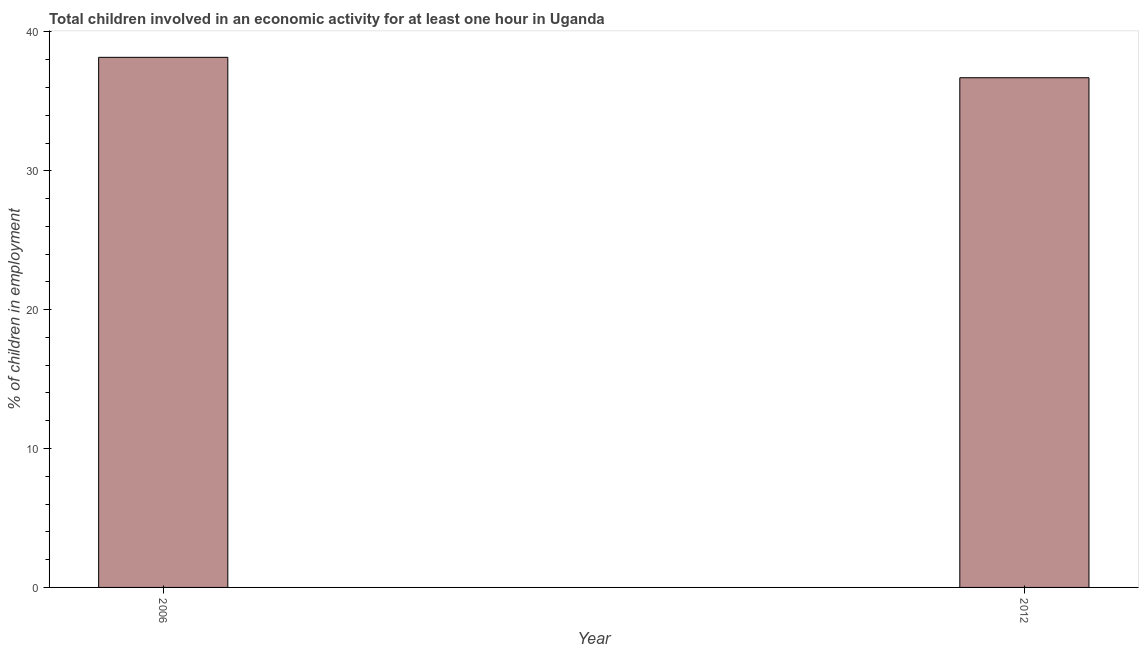Does the graph contain any zero values?
Ensure brevity in your answer.  No. Does the graph contain grids?
Offer a very short reply. No. What is the title of the graph?
Make the answer very short. Total children involved in an economic activity for at least one hour in Uganda. What is the label or title of the Y-axis?
Provide a short and direct response. % of children in employment. What is the percentage of children in employment in 2006?
Offer a terse response. 38.17. Across all years, what is the maximum percentage of children in employment?
Make the answer very short. 38.17. Across all years, what is the minimum percentage of children in employment?
Ensure brevity in your answer.  36.7. What is the sum of the percentage of children in employment?
Provide a succinct answer. 74.87. What is the difference between the percentage of children in employment in 2006 and 2012?
Ensure brevity in your answer.  1.47. What is the average percentage of children in employment per year?
Give a very brief answer. 37.44. What is the median percentage of children in employment?
Provide a succinct answer. 37.44. In how many years, is the percentage of children in employment greater than 38 %?
Offer a terse response. 1. In how many years, is the percentage of children in employment greater than the average percentage of children in employment taken over all years?
Offer a terse response. 1. How many bars are there?
Your answer should be very brief. 2. What is the difference between two consecutive major ticks on the Y-axis?
Your response must be concise. 10. What is the % of children in employment of 2006?
Make the answer very short. 38.17. What is the % of children in employment of 2012?
Your answer should be very brief. 36.7. What is the difference between the % of children in employment in 2006 and 2012?
Give a very brief answer. 1.47. 